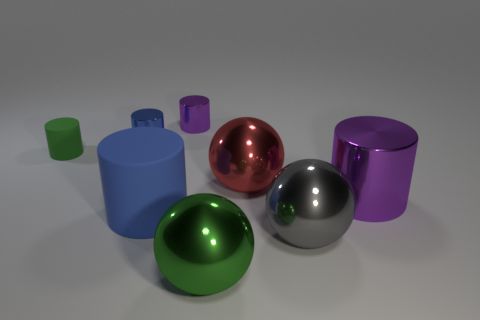Are there any other large things of the same shape as the gray object?
Your answer should be compact. Yes. Are there an equal number of small purple shiny things behind the small purple metal object and small blue metal cylinders?
Provide a short and direct response. No. What material is the blue thing that is left of the large object that is on the left side of the tiny purple shiny thing?
Your response must be concise. Metal. There is a gray object; what shape is it?
Offer a terse response. Sphere. Is the number of large things on the right side of the large red ball the same as the number of small purple metal objects in front of the green rubber cylinder?
Your answer should be very brief. No. There is a large cylinder in front of the big purple shiny cylinder; does it have the same color as the tiny shiny cylinder that is on the right side of the small blue cylinder?
Provide a succinct answer. No. Are there more blue metal things that are on the right side of the large purple shiny thing than tiny red rubber cylinders?
Your response must be concise. No. There is a tiny purple thing that is made of the same material as the big gray ball; what shape is it?
Provide a short and direct response. Cylinder. There is a purple metallic object on the right side of the gray thing; is its size the same as the tiny blue metal thing?
Your response must be concise. No. There is a blue object that is behind the metal cylinder on the right side of the red metal thing; what shape is it?
Your answer should be compact. Cylinder. 